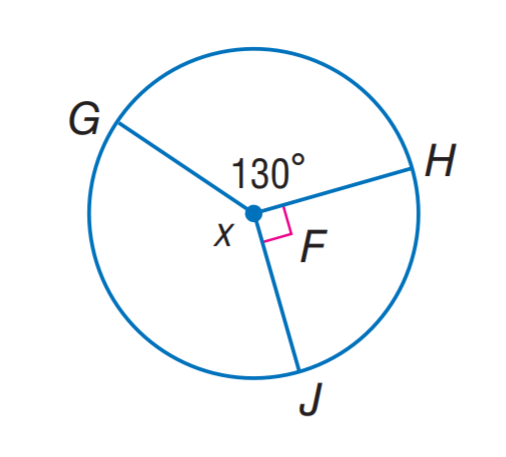Question: Find x.
Choices:
A. 90
B. 110
C. 130
D. 140
Answer with the letter. Answer: D 